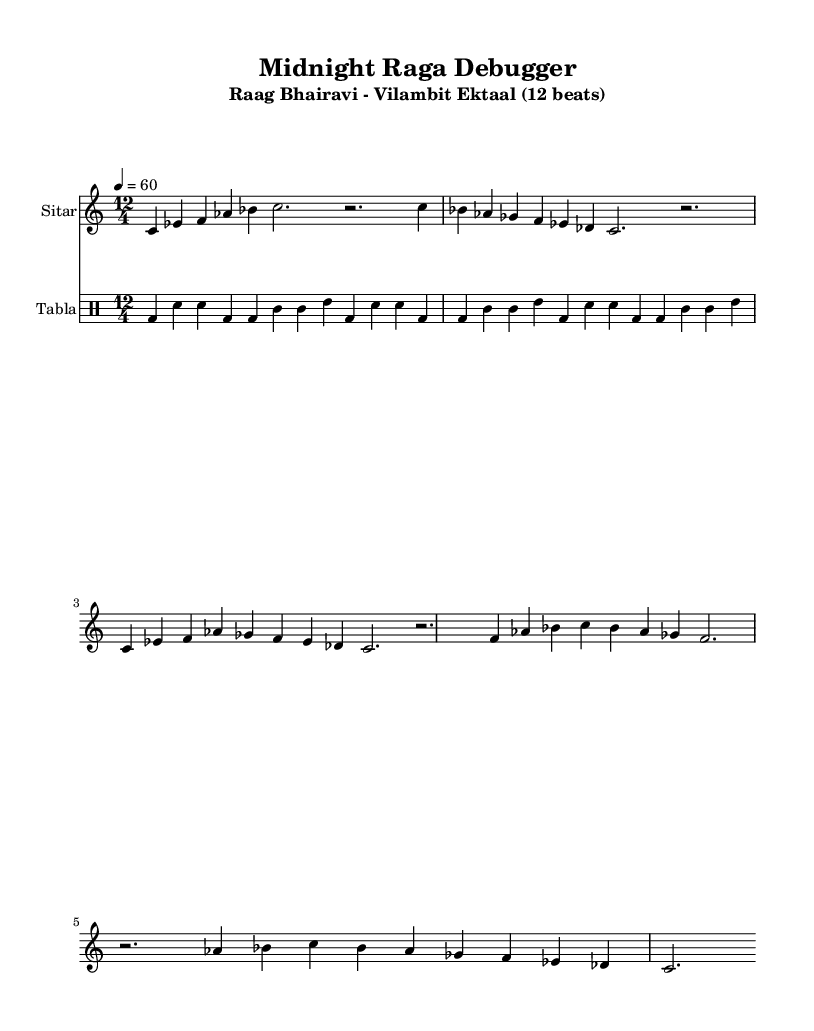What is the key signature of this music? The key signature is C major, which has no sharps or flats.
Answer: C major What is the time signature of this music? The time signature is shown at the beginning of the score, indicating a total of 12 beats per measure.
Answer: 12/4 What is the tempo marking of this piece? The tempo marking of the piece is indicated in beats per minute. In this score, it is set to 60 beats per minute.
Answer: 60 How many beats are in each measure? The time signature 12/4 indicates that there are 12 beats in each measure.
Answer: 12 What instrument is primarily used for the melody? The instrument name in the staff indicates that the primary instrument for the melody is the Sitar.
Answer: Sitar What type of raga is this piece? The title indicates that it is a Vilambit Ektaal raga, which is a slow-moving raga played in 12 beats.
Answer: Vilambit Ektaal How many phrases are in the melody section? Upon analysis of the melody, there are five distinct phrases separated by bars within the music.
Answer: Five 